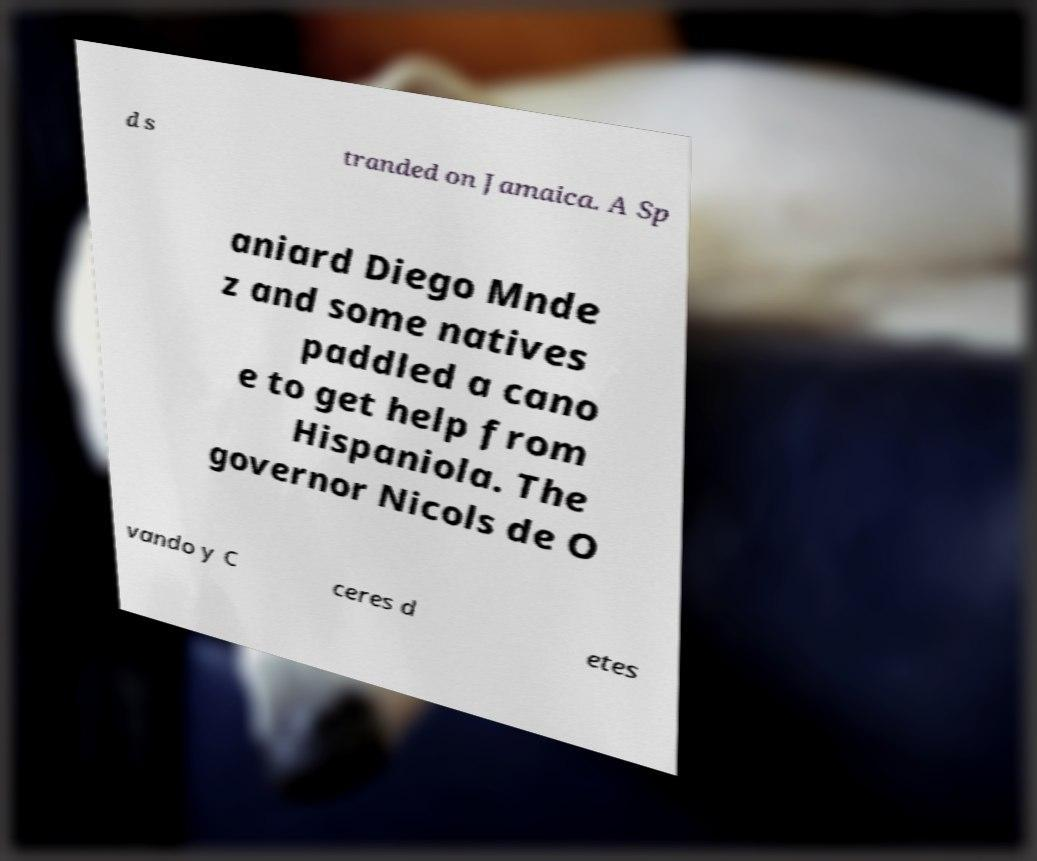For documentation purposes, I need the text within this image transcribed. Could you provide that? d s tranded on Jamaica. A Sp aniard Diego Mnde z and some natives paddled a cano e to get help from Hispaniola. The governor Nicols de O vando y C ceres d etes 